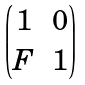<formula> <loc_0><loc_0><loc_500><loc_500>\begin{pmatrix} 1 & 0 \\ F & 1 \end{pmatrix}</formula> 